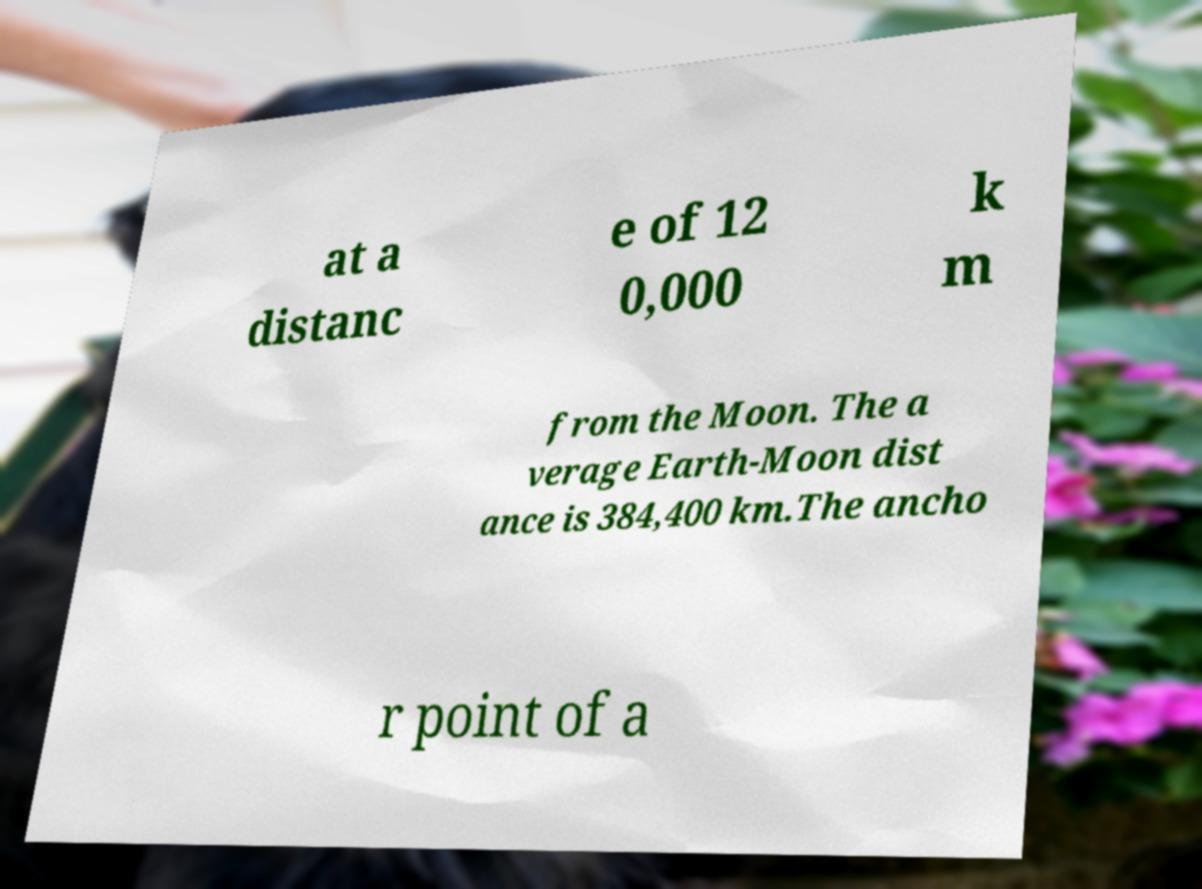For documentation purposes, I need the text within this image transcribed. Could you provide that? at a distanc e of 12 0,000 k m from the Moon. The a verage Earth-Moon dist ance is 384,400 km.The ancho r point of a 